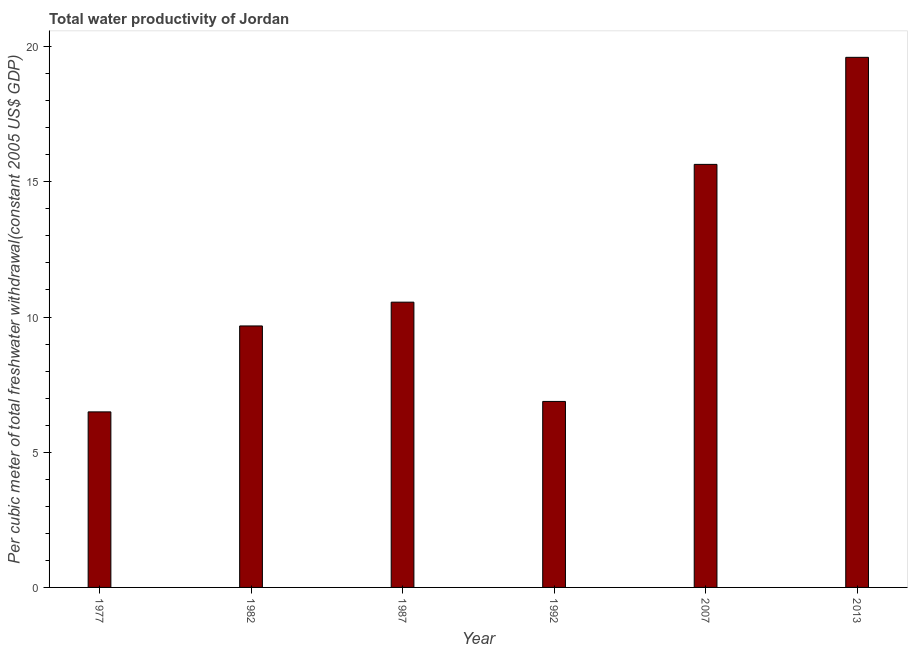Does the graph contain grids?
Your response must be concise. No. What is the title of the graph?
Your answer should be very brief. Total water productivity of Jordan. What is the label or title of the Y-axis?
Make the answer very short. Per cubic meter of total freshwater withdrawal(constant 2005 US$ GDP). What is the total water productivity in 2013?
Your answer should be compact. 19.6. Across all years, what is the maximum total water productivity?
Your answer should be very brief. 19.6. Across all years, what is the minimum total water productivity?
Give a very brief answer. 6.49. In which year was the total water productivity minimum?
Make the answer very short. 1977. What is the sum of the total water productivity?
Offer a terse response. 68.84. What is the difference between the total water productivity in 1982 and 1987?
Keep it short and to the point. -0.88. What is the average total water productivity per year?
Provide a short and direct response. 11.47. What is the median total water productivity?
Provide a short and direct response. 10.11. What is the ratio of the total water productivity in 1982 to that in 2007?
Offer a very short reply. 0.62. What is the difference between the highest and the second highest total water productivity?
Make the answer very short. 3.96. Is the sum of the total water productivity in 1982 and 2007 greater than the maximum total water productivity across all years?
Your response must be concise. Yes. What is the difference between the highest and the lowest total water productivity?
Provide a succinct answer. 13.11. In how many years, is the total water productivity greater than the average total water productivity taken over all years?
Make the answer very short. 2. Are all the bars in the graph horizontal?
Your answer should be compact. No. What is the difference between two consecutive major ticks on the Y-axis?
Provide a short and direct response. 5. Are the values on the major ticks of Y-axis written in scientific E-notation?
Ensure brevity in your answer.  No. What is the Per cubic meter of total freshwater withdrawal(constant 2005 US$ GDP) of 1977?
Provide a succinct answer. 6.49. What is the Per cubic meter of total freshwater withdrawal(constant 2005 US$ GDP) in 1982?
Keep it short and to the point. 9.67. What is the Per cubic meter of total freshwater withdrawal(constant 2005 US$ GDP) in 1987?
Provide a short and direct response. 10.55. What is the Per cubic meter of total freshwater withdrawal(constant 2005 US$ GDP) of 1992?
Offer a terse response. 6.88. What is the Per cubic meter of total freshwater withdrawal(constant 2005 US$ GDP) of 2007?
Your response must be concise. 15.64. What is the Per cubic meter of total freshwater withdrawal(constant 2005 US$ GDP) of 2013?
Offer a terse response. 19.6. What is the difference between the Per cubic meter of total freshwater withdrawal(constant 2005 US$ GDP) in 1977 and 1982?
Your answer should be very brief. -3.18. What is the difference between the Per cubic meter of total freshwater withdrawal(constant 2005 US$ GDP) in 1977 and 1987?
Provide a succinct answer. -4.06. What is the difference between the Per cubic meter of total freshwater withdrawal(constant 2005 US$ GDP) in 1977 and 1992?
Offer a terse response. -0.39. What is the difference between the Per cubic meter of total freshwater withdrawal(constant 2005 US$ GDP) in 1977 and 2007?
Make the answer very short. -9.15. What is the difference between the Per cubic meter of total freshwater withdrawal(constant 2005 US$ GDP) in 1977 and 2013?
Make the answer very short. -13.11. What is the difference between the Per cubic meter of total freshwater withdrawal(constant 2005 US$ GDP) in 1982 and 1987?
Ensure brevity in your answer.  -0.88. What is the difference between the Per cubic meter of total freshwater withdrawal(constant 2005 US$ GDP) in 1982 and 1992?
Keep it short and to the point. 2.79. What is the difference between the Per cubic meter of total freshwater withdrawal(constant 2005 US$ GDP) in 1982 and 2007?
Offer a terse response. -5.97. What is the difference between the Per cubic meter of total freshwater withdrawal(constant 2005 US$ GDP) in 1982 and 2013?
Ensure brevity in your answer.  -9.93. What is the difference between the Per cubic meter of total freshwater withdrawal(constant 2005 US$ GDP) in 1987 and 1992?
Make the answer very short. 3.67. What is the difference between the Per cubic meter of total freshwater withdrawal(constant 2005 US$ GDP) in 1987 and 2007?
Offer a terse response. -5.09. What is the difference between the Per cubic meter of total freshwater withdrawal(constant 2005 US$ GDP) in 1987 and 2013?
Offer a very short reply. -9.05. What is the difference between the Per cubic meter of total freshwater withdrawal(constant 2005 US$ GDP) in 1992 and 2007?
Offer a terse response. -8.77. What is the difference between the Per cubic meter of total freshwater withdrawal(constant 2005 US$ GDP) in 1992 and 2013?
Your response must be concise. -12.73. What is the difference between the Per cubic meter of total freshwater withdrawal(constant 2005 US$ GDP) in 2007 and 2013?
Keep it short and to the point. -3.96. What is the ratio of the Per cubic meter of total freshwater withdrawal(constant 2005 US$ GDP) in 1977 to that in 1982?
Ensure brevity in your answer.  0.67. What is the ratio of the Per cubic meter of total freshwater withdrawal(constant 2005 US$ GDP) in 1977 to that in 1987?
Offer a very short reply. 0.61. What is the ratio of the Per cubic meter of total freshwater withdrawal(constant 2005 US$ GDP) in 1977 to that in 1992?
Keep it short and to the point. 0.94. What is the ratio of the Per cubic meter of total freshwater withdrawal(constant 2005 US$ GDP) in 1977 to that in 2007?
Provide a short and direct response. 0.41. What is the ratio of the Per cubic meter of total freshwater withdrawal(constant 2005 US$ GDP) in 1977 to that in 2013?
Keep it short and to the point. 0.33. What is the ratio of the Per cubic meter of total freshwater withdrawal(constant 2005 US$ GDP) in 1982 to that in 1987?
Offer a terse response. 0.92. What is the ratio of the Per cubic meter of total freshwater withdrawal(constant 2005 US$ GDP) in 1982 to that in 1992?
Provide a short and direct response. 1.41. What is the ratio of the Per cubic meter of total freshwater withdrawal(constant 2005 US$ GDP) in 1982 to that in 2007?
Keep it short and to the point. 0.62. What is the ratio of the Per cubic meter of total freshwater withdrawal(constant 2005 US$ GDP) in 1982 to that in 2013?
Your answer should be compact. 0.49. What is the ratio of the Per cubic meter of total freshwater withdrawal(constant 2005 US$ GDP) in 1987 to that in 1992?
Your response must be concise. 1.53. What is the ratio of the Per cubic meter of total freshwater withdrawal(constant 2005 US$ GDP) in 1987 to that in 2007?
Offer a very short reply. 0.67. What is the ratio of the Per cubic meter of total freshwater withdrawal(constant 2005 US$ GDP) in 1987 to that in 2013?
Provide a short and direct response. 0.54. What is the ratio of the Per cubic meter of total freshwater withdrawal(constant 2005 US$ GDP) in 1992 to that in 2007?
Offer a very short reply. 0.44. What is the ratio of the Per cubic meter of total freshwater withdrawal(constant 2005 US$ GDP) in 1992 to that in 2013?
Give a very brief answer. 0.35. What is the ratio of the Per cubic meter of total freshwater withdrawal(constant 2005 US$ GDP) in 2007 to that in 2013?
Keep it short and to the point. 0.8. 